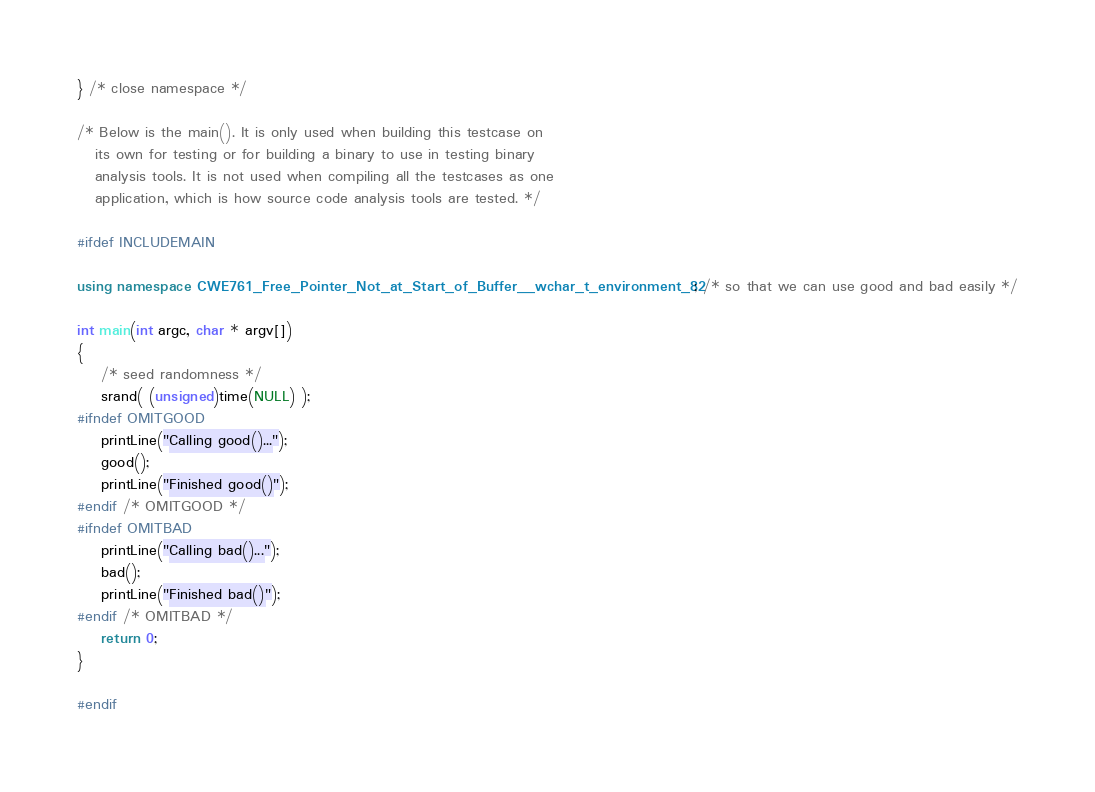Convert code to text. <code><loc_0><loc_0><loc_500><loc_500><_C++_>} /* close namespace */

/* Below is the main(). It is only used when building this testcase on
   its own for testing or for building a binary to use in testing binary
   analysis tools. It is not used when compiling all the testcases as one
   application, which is how source code analysis tools are tested. */

#ifdef INCLUDEMAIN

using namespace CWE761_Free_Pointer_Not_at_Start_of_Buffer__wchar_t_environment_82; /* so that we can use good and bad easily */

int main(int argc, char * argv[])
{
    /* seed randomness */
    srand( (unsigned)time(NULL) );
#ifndef OMITGOOD
    printLine("Calling good()...");
    good();
    printLine("Finished good()");
#endif /* OMITGOOD */
#ifndef OMITBAD
    printLine("Calling bad()...");
    bad();
    printLine("Finished bad()");
#endif /* OMITBAD */
    return 0;
}

#endif
</code> 